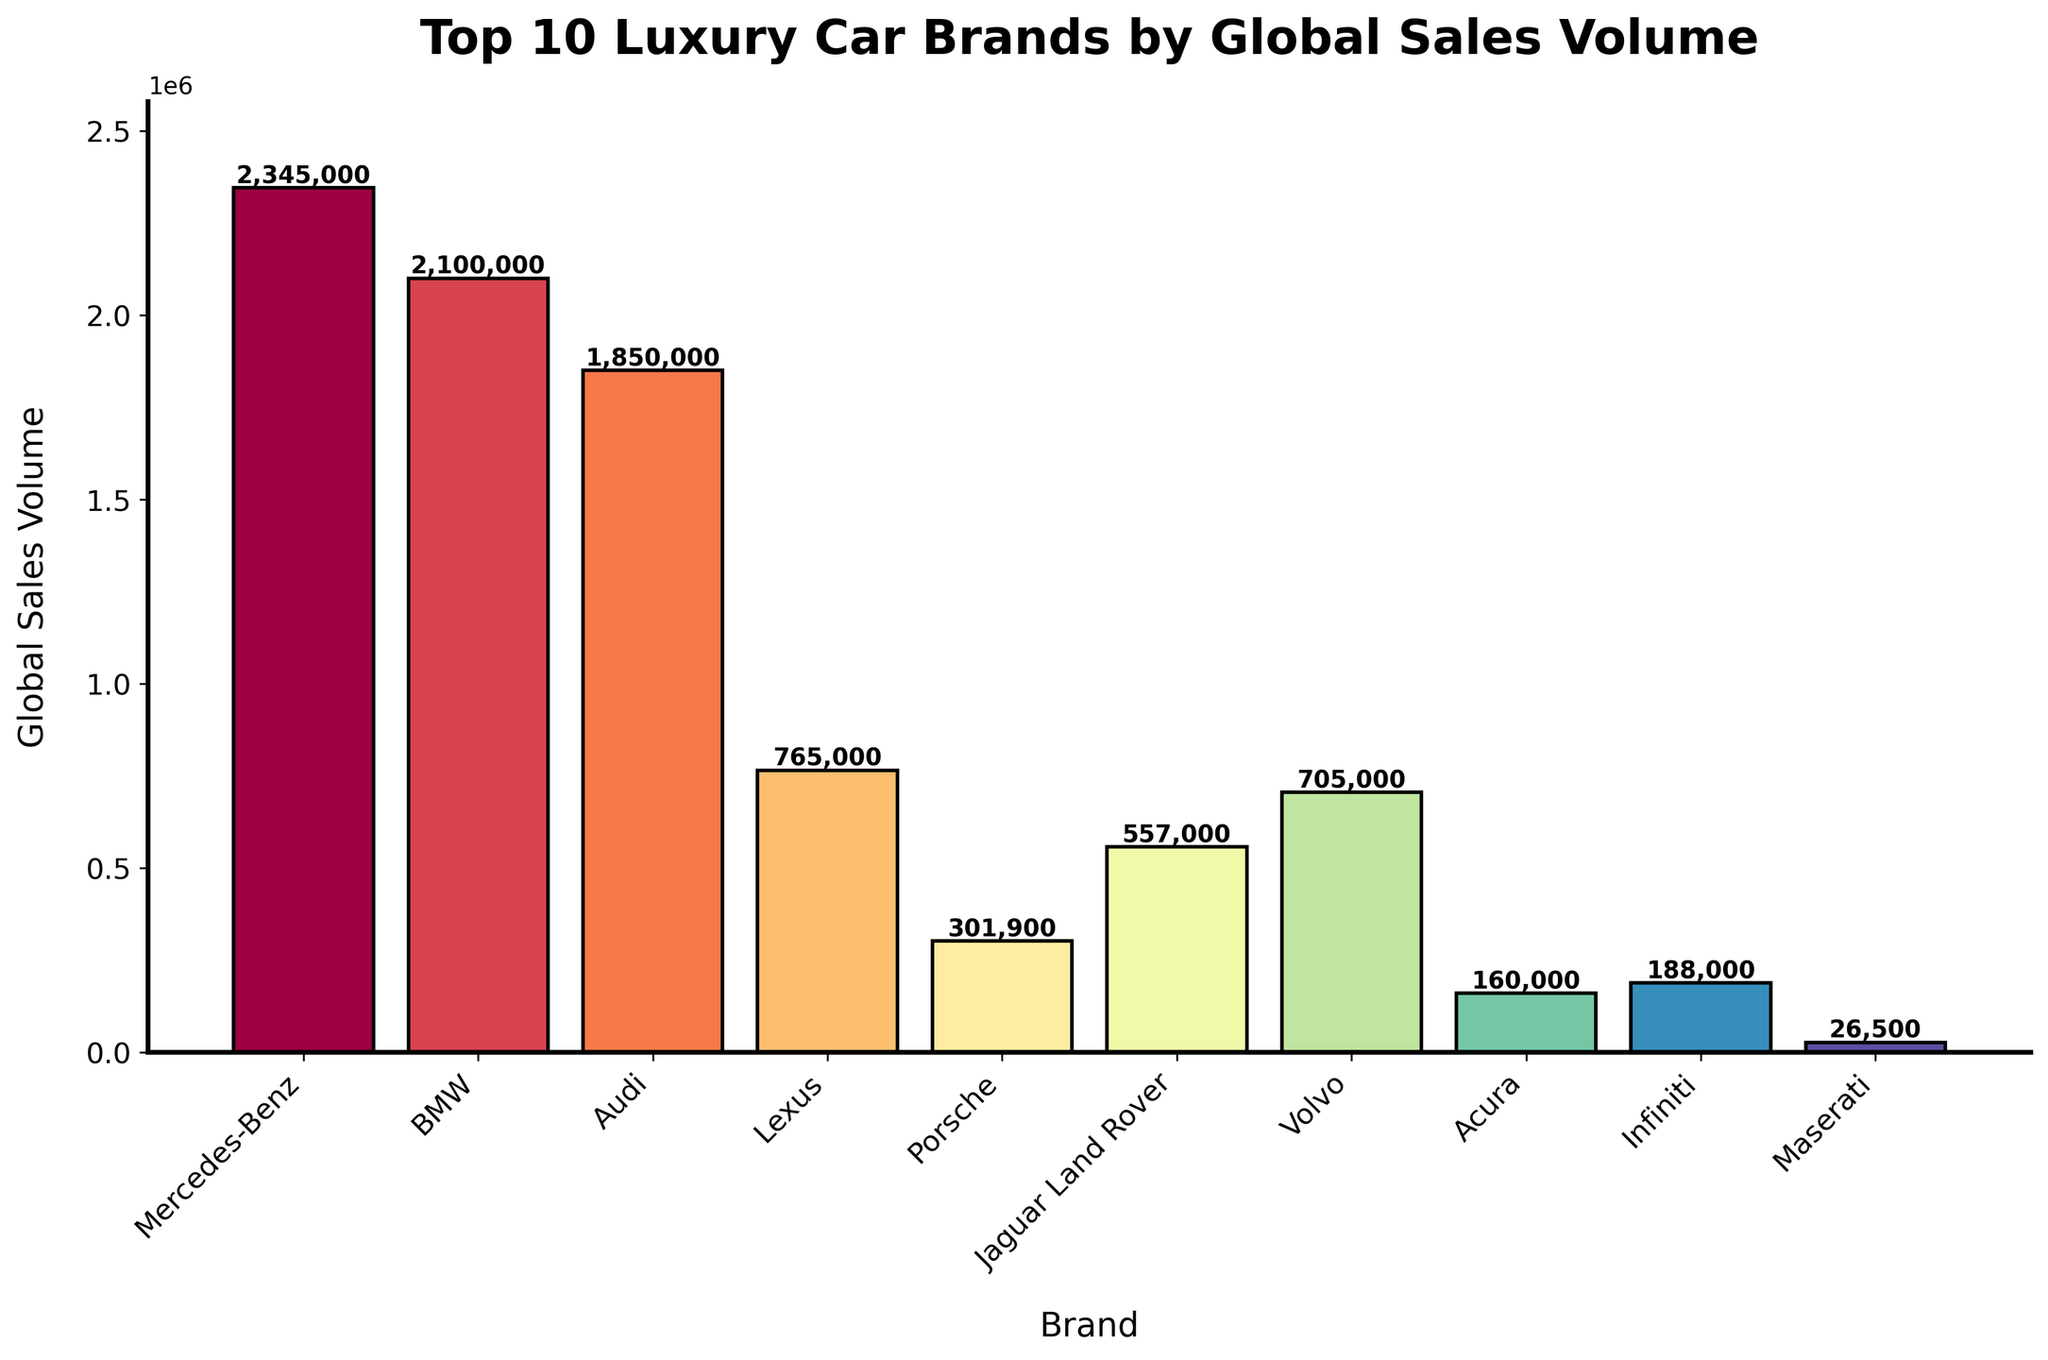Which brand has the highest global sales volume? By looking at the height of the bars, the tallest bar corresponds to Mercedes-Benz. This indicates that Mercedes-Benz has the highest global sales volume.
Answer: Mercedes-Benz Which two brands have the lowest global sales volumes? The bars for Maserati and Acura are the shortest. Therefore, these two brands have the lowest global sales volumes.
Answer: Maserati and Acura What's the difference in global sales volume between Mercedes-Benz and BMW? Mercedes-Benz has a sales volume of 2,345,000 and BMW has 2,100,000. Subtracting BMW's volume from Mercedes-Benz's volume gives 2,345,000 - 2,100,000 = 245,000.
Answer: 245,000 How does the global sales volume of Lexus compare to that of Volvo? Lexus has a global sales volume of 765,000, whereas Volvo has 705,000. Comparing these values, Lexus' sales are higher.
Answer: Lexus is higher Which brand has a global sales volume closest to 1,000,000? Observing the sales volumes, Jaguar Land Rover with a volume of 557,000 is the closest to 1,000,000 among the brands shown.
Answer: Jaguar Land Rover How many brands have a global sales volume exceeding 1,000,000? Brands with heights of bars exceeding the 1,000,000 mark include Mercedes-Benz, BMW, and Audi. There are three such brands.
Answer: 3 What is the sum of the global sales volumes for Porsche and Volvo? Porsche has a sales volume of 301,900 and Volvo has 705,000. Summing these gives 301,900 + 705,000 = 1,006,900.
Answer: 1,006,900 What percentage of the total sales volume do Maserati and Acura together account for? Add the sales volumes of Maserati and Acura: 26,500 + 160,000 = 186,500. The total sales volume for all brands is 7,574,400. So, the percentage is (186,500 / 7,574,400) * 100 ≈ 2.46%.
Answer: 2.46% Which brand's global sales bar is roughly halfway in height between the tallest and shortest bars? The tallest bar is for Mercedes-Benz and the shortest is for Maserati. Audi appears to be roughly halfway between these two extremes.
Answer: Audi 